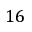<formula> <loc_0><loc_0><loc_500><loc_500>1 6</formula> 